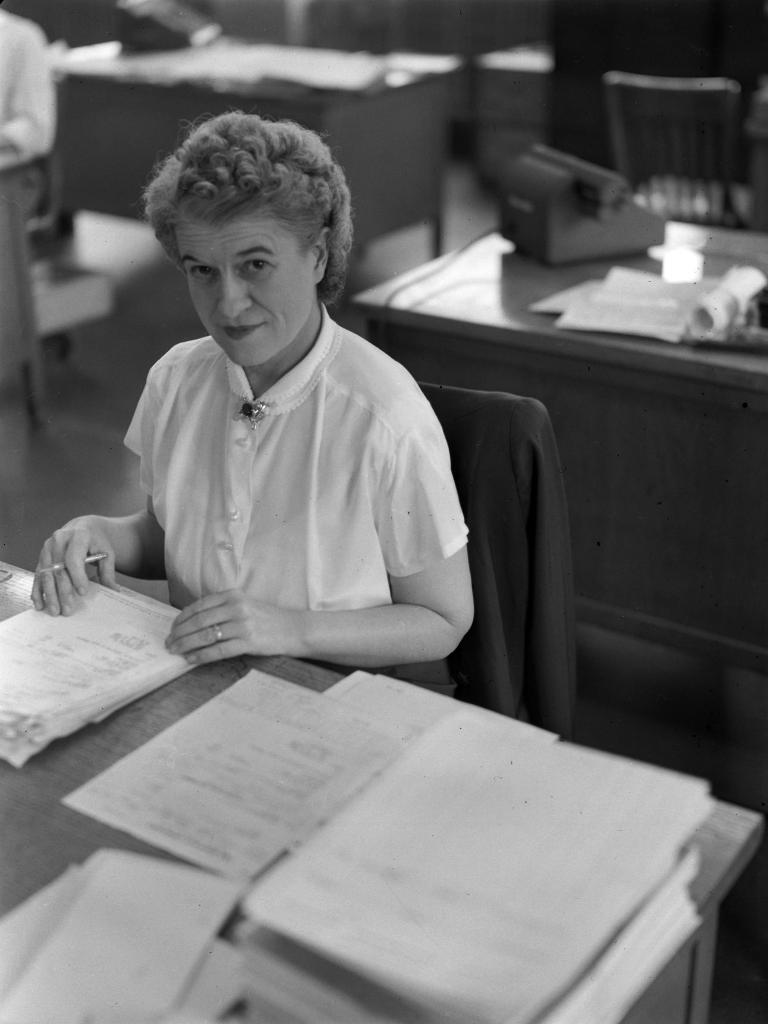Who is in the image? There is a woman in the image. What is the woman doing in the image? The woman is sitting in a chair and holding papers. Where are the papers located in the image? The papers are on a table. What else can be seen on the table in the background? There are papers on the background table. What other object is present on the background table? There is a telephone on the background table. What type of ink is being used to write on the papers in the image? There is no indication in the image that anyone is writing on the papers, and therefore no ink can be observed. 